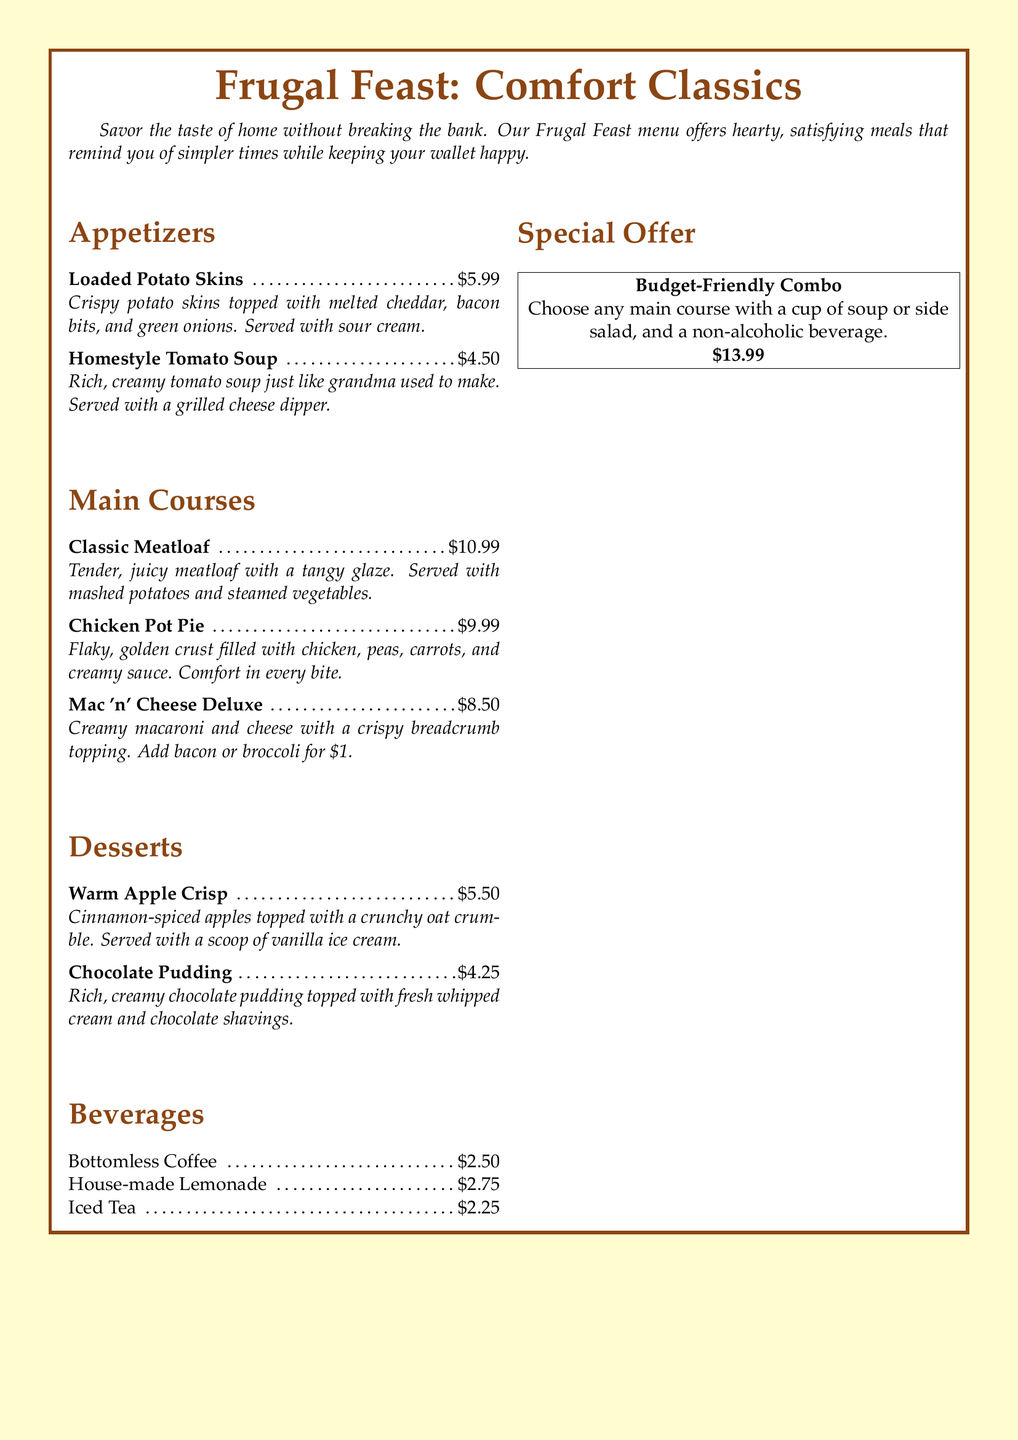what is the price of Loaded Potato Skins? The price of Loaded Potato Skins is listed in the menu as $5.99.
Answer: $5.99 what dessert is served with vanilla ice cream? The dessert Warm Apple Crisp is served with a scoop of vanilla ice cream.
Answer: Warm Apple Crisp how much does Chicken Pot Pie cost? The cost of Chicken Pot Pie is displayed as $9.99 in the menu.
Answer: $9.99 which beverage is the cheapest option? The cheapest beverage on the menu is Iced Tea, which is priced at $2.25.
Answer: $2.25 how much does the Budget-Friendly Combo cost? The Budget-Friendly Combo price is stated as $13.99 in the special offer section.
Answer: $13.99 what two add-ons are available for Mac 'n' Cheese Deluxe? The available add-ons for Mac 'n' Cheese Deluxe are bacon or broccoli for an additional cost.
Answer: bacon or broccoli what is the main ingredient in the Homestyle Tomato Soup? The main ingredient of Homestyle Tomato Soup is tomato, as it is described as rich, creamy tomato soup.
Answer: tomato which item is described as "comfort in every bite"? The Chicken Pot Pie is described with the phrase "comfort in every bite."
Answer: Chicken Pot Pie 